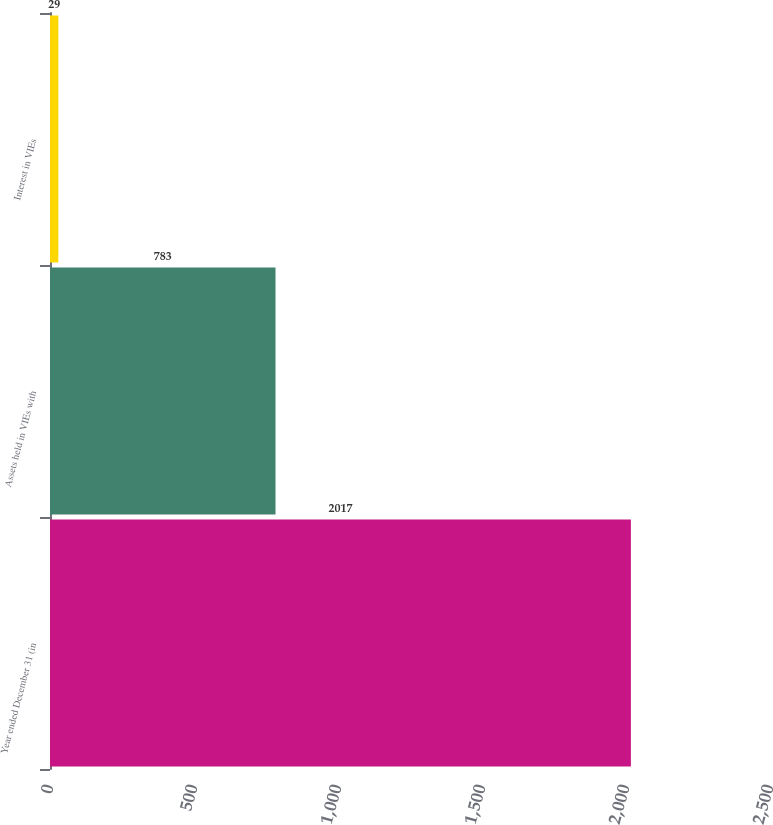<chart> <loc_0><loc_0><loc_500><loc_500><bar_chart><fcel>Year ended December 31 (in<fcel>Assets held in VIEs with<fcel>Interest in VIEs<nl><fcel>2017<fcel>783<fcel>29<nl></chart> 